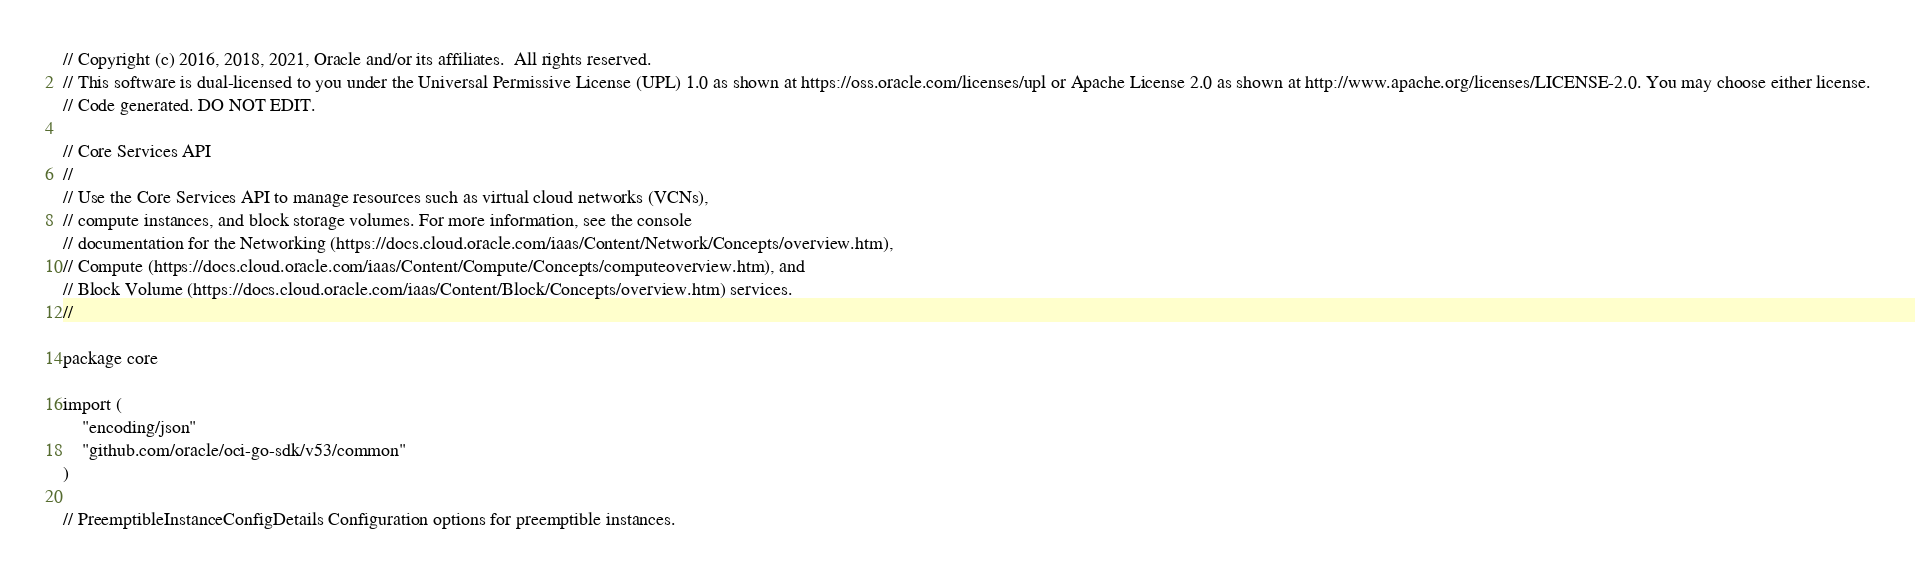<code> <loc_0><loc_0><loc_500><loc_500><_Go_>// Copyright (c) 2016, 2018, 2021, Oracle and/or its affiliates.  All rights reserved.
// This software is dual-licensed to you under the Universal Permissive License (UPL) 1.0 as shown at https://oss.oracle.com/licenses/upl or Apache License 2.0 as shown at http://www.apache.org/licenses/LICENSE-2.0. You may choose either license.
// Code generated. DO NOT EDIT.

// Core Services API
//
// Use the Core Services API to manage resources such as virtual cloud networks (VCNs),
// compute instances, and block storage volumes. For more information, see the console
// documentation for the Networking (https://docs.cloud.oracle.com/iaas/Content/Network/Concepts/overview.htm),
// Compute (https://docs.cloud.oracle.com/iaas/Content/Compute/Concepts/computeoverview.htm), and
// Block Volume (https://docs.cloud.oracle.com/iaas/Content/Block/Concepts/overview.htm) services.
//

package core

import (
	"encoding/json"
	"github.com/oracle/oci-go-sdk/v53/common"
)

// PreemptibleInstanceConfigDetails Configuration options for preemptible instances.</code> 